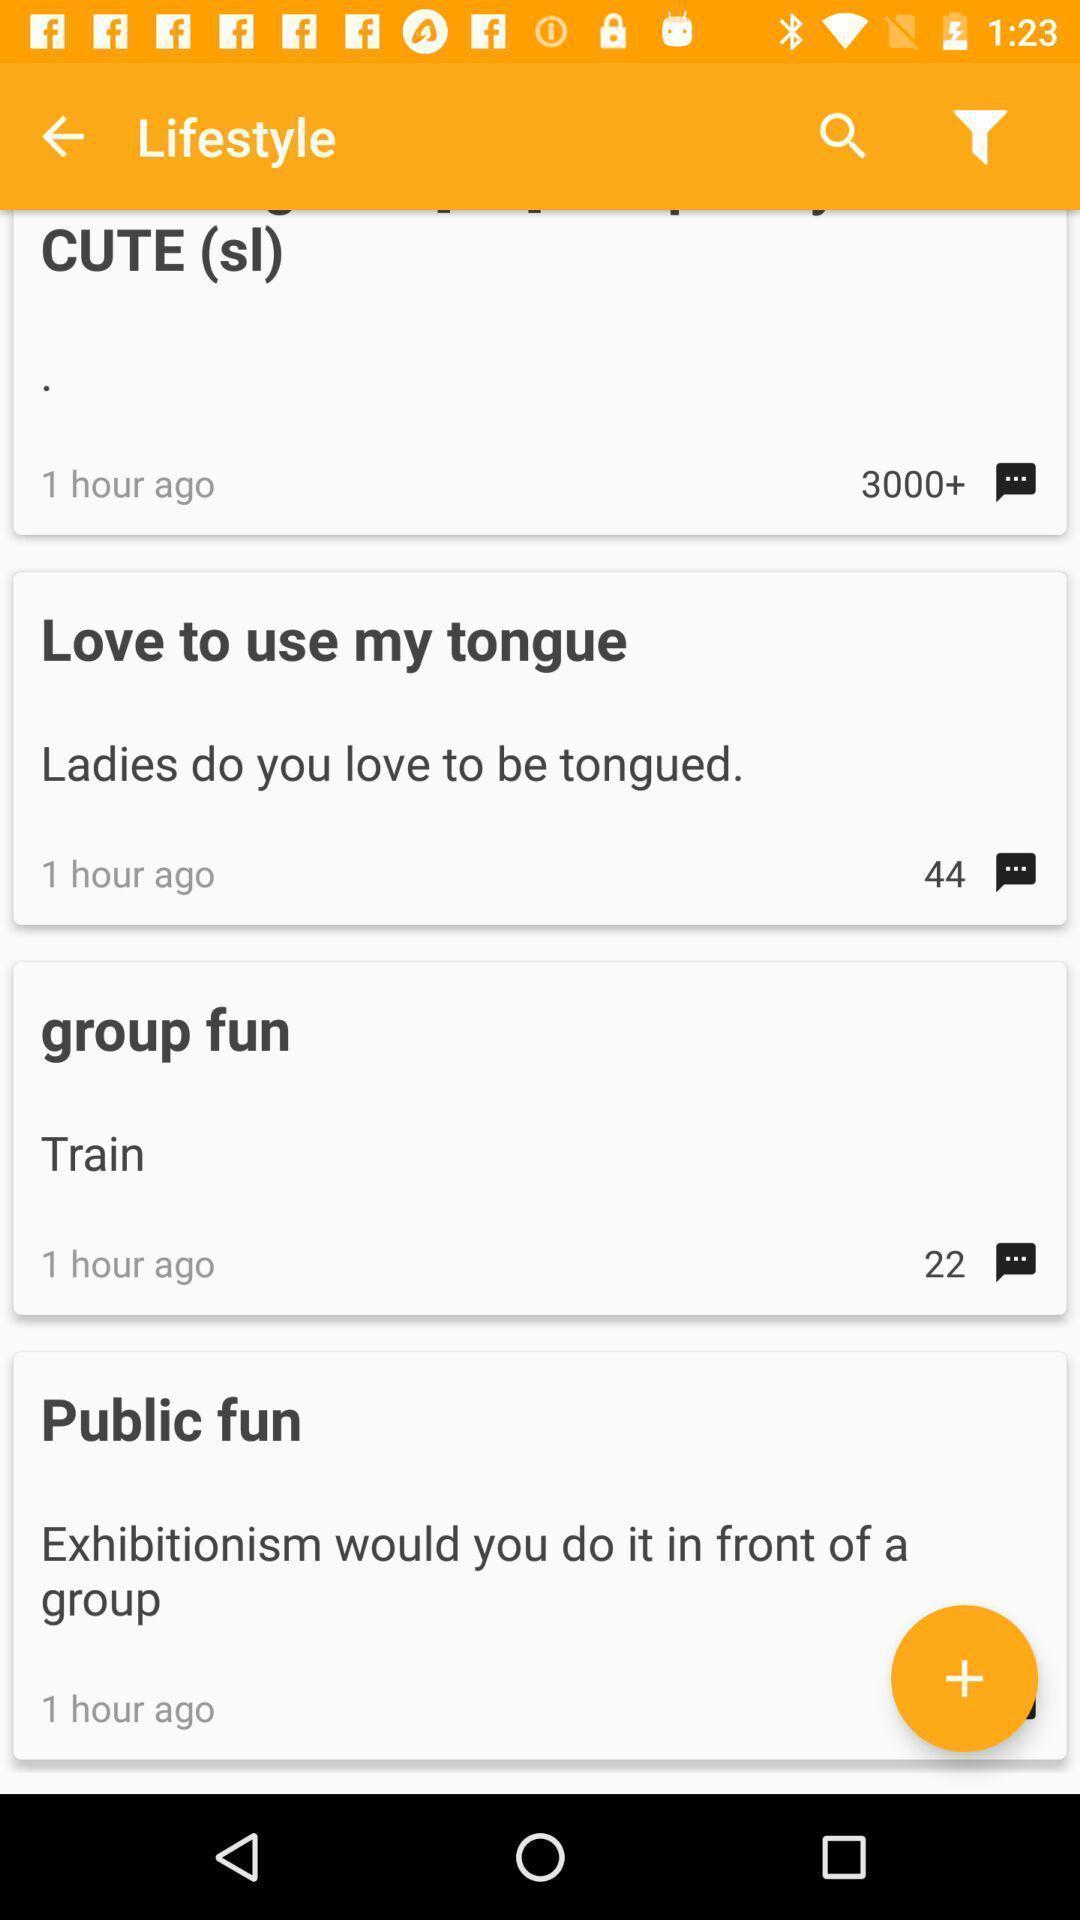What details can you identify in this image? Screen displaying multiple room names in a chatting application. 